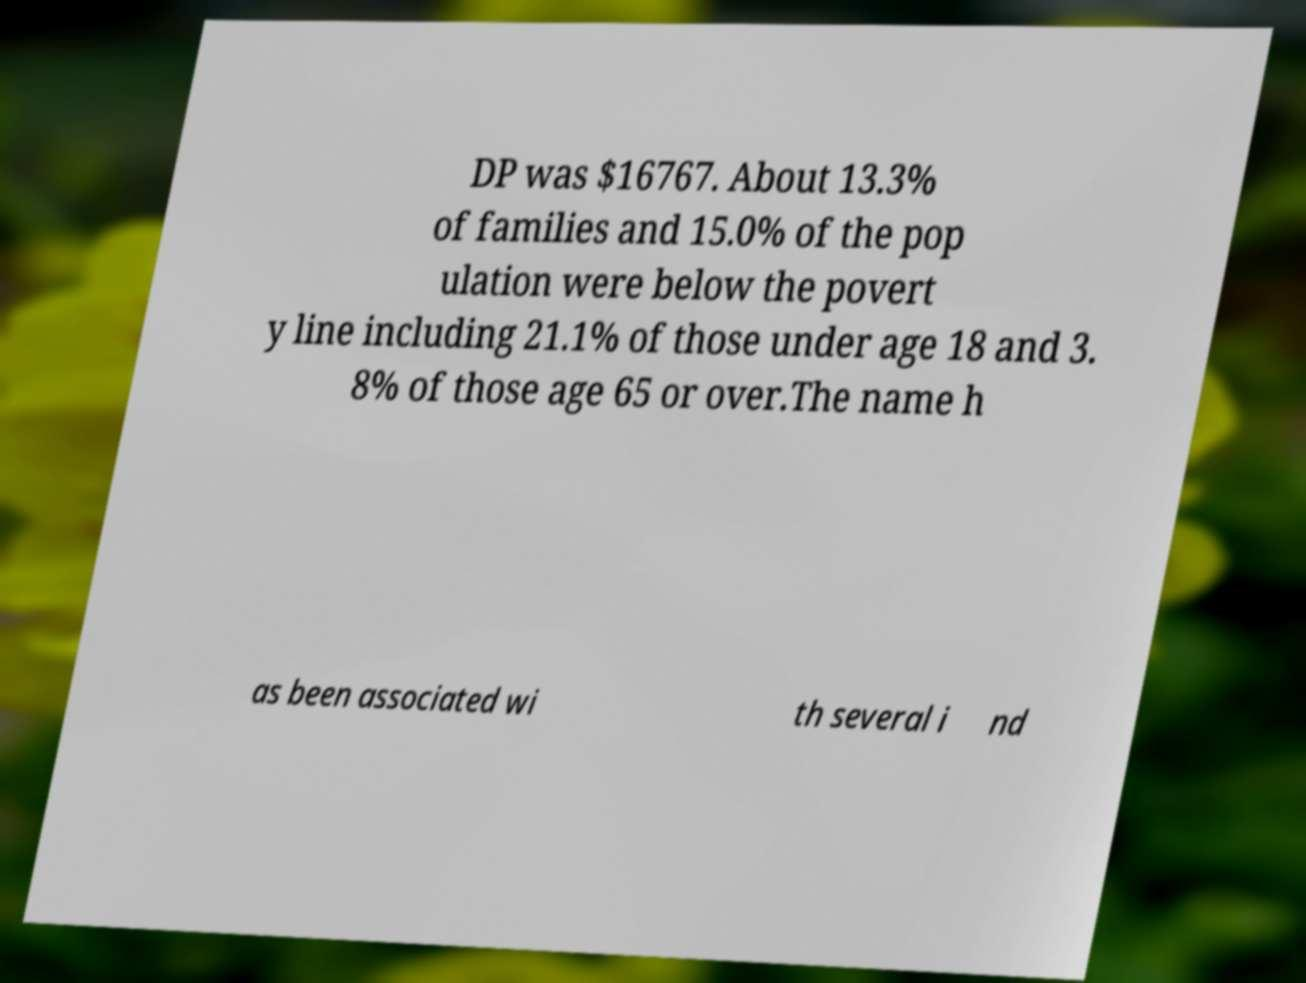For documentation purposes, I need the text within this image transcribed. Could you provide that? DP was $16767. About 13.3% of families and 15.0% of the pop ulation were below the povert y line including 21.1% of those under age 18 and 3. 8% of those age 65 or over.The name h as been associated wi th several i nd 